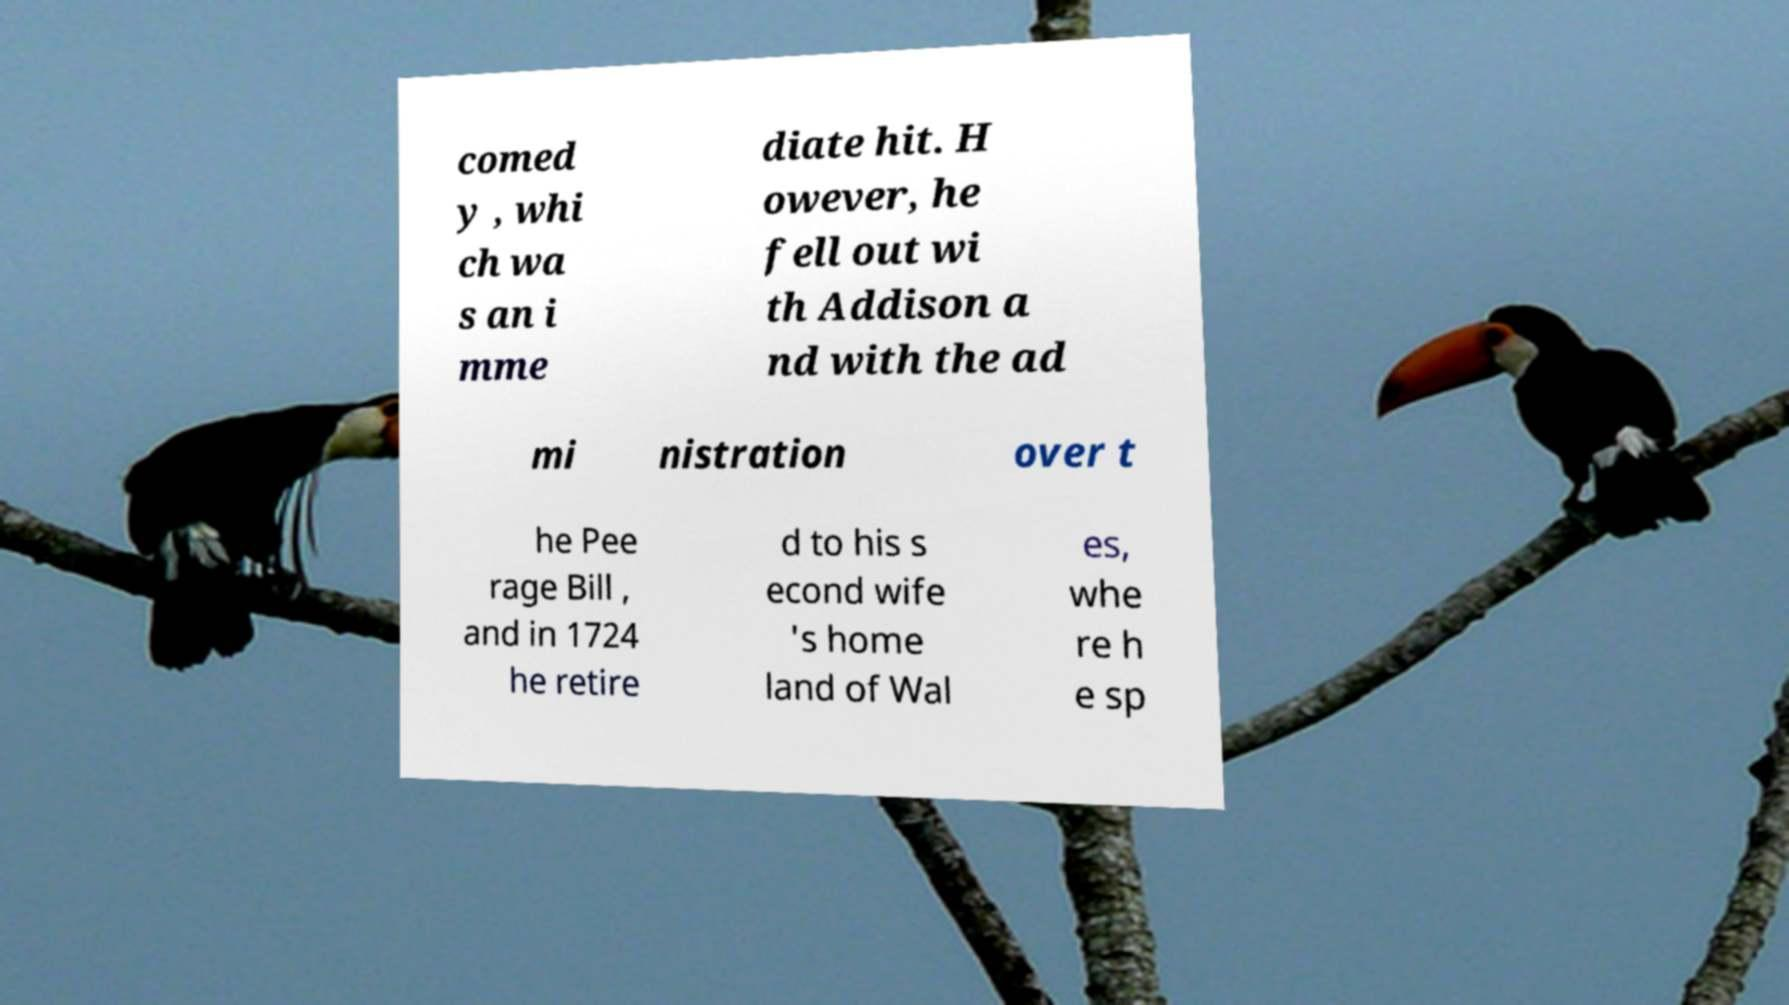Can you read and provide the text displayed in the image?This photo seems to have some interesting text. Can you extract and type it out for me? comed y , whi ch wa s an i mme diate hit. H owever, he fell out wi th Addison a nd with the ad mi nistration over t he Pee rage Bill , and in 1724 he retire d to his s econd wife 's home land of Wal es, whe re h e sp 